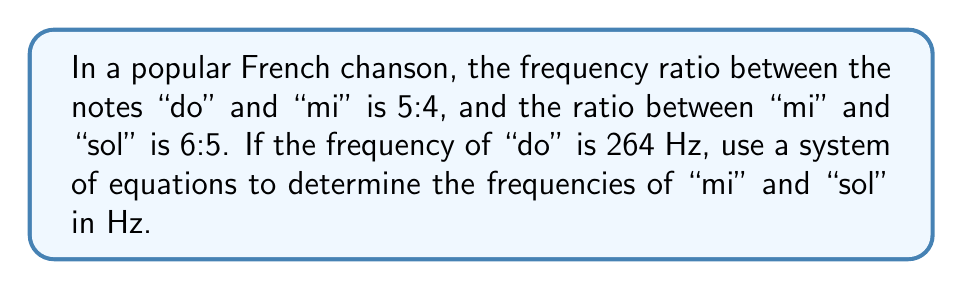Solve this math problem. Let's approach this step-by-step:

1) Let $x$ be the frequency of "mi" and $y$ be the frequency of "sol" in Hz.

2) Given information:
   - Frequency of "do" is 264 Hz
   - Ratio of "do" to "mi" is 5:4
   - Ratio of "mi" to "sol" is 6:5

3) We can set up two equations based on these ratios:

   Equation 1: $\frac{264}{x} = \frac{4}{5}$ (ratio of "do" to "mi")
   Equation 2: $\frac{x}{y} = \frac{5}{6}$ (ratio of "mi" to "sol")

4) Let's solve Equation 1 for $x$:
   $$\frac{264}{x} = \frac{4}{5}$$
   $$264 = \frac{4x}{5}$$
   $$264 \cdot 5 = 4x$$
   $$1320 = 4x$$
   $$x = 330$$

   So, the frequency of "mi" is 330 Hz.

5) Now, we can use this value in Equation 2 to solve for $y$:
   $$\frac{330}{y} = \frac{5}{6}$$
   $$330 = \frac{5y}{6}$$
   $$330 \cdot 6 = 5y$$
   $$1980 = 5y$$
   $$y = 396$$

   Therefore, the frequency of "sol" is 396 Hz.
Answer: mi: 330 Hz, sol: 396 Hz 